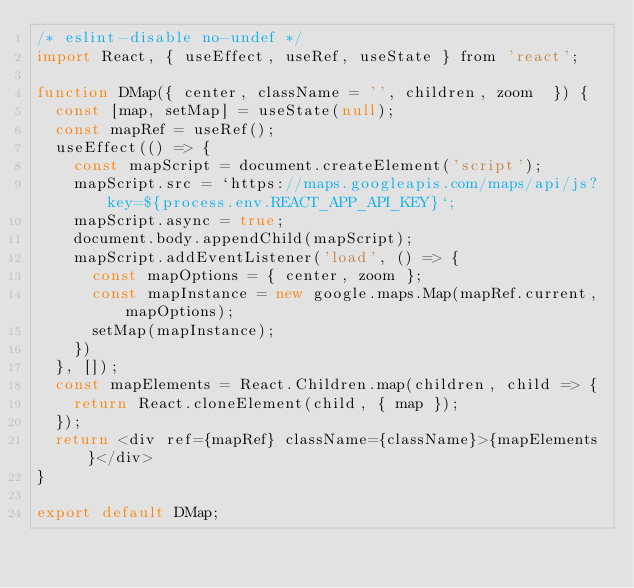Convert code to text. <code><loc_0><loc_0><loc_500><loc_500><_JavaScript_>/* eslint-disable no-undef */
import React, { useEffect, useRef, useState } from 'react';

function DMap({ center, className = '', children, zoom  }) {
  const [map, setMap] = useState(null);
  const mapRef = useRef();
  useEffect(() => {
    const mapScript = document.createElement('script');
    mapScript.src = `https://maps.googleapis.com/maps/api/js?key=${process.env.REACT_APP_API_KEY}`;
    mapScript.async = true;
    document.body.appendChild(mapScript);
    mapScript.addEventListener('load', () => {
      const mapOptions = { center, zoom };
      const mapInstance = new google.maps.Map(mapRef.current, mapOptions);
      setMap(mapInstance);
    })
  }, []);
  const mapElements = React.Children.map(children, child => {
    return React.cloneElement(child, { map });
  });
  return <div ref={mapRef} className={className}>{mapElements}</div>
}

export default DMap;</code> 